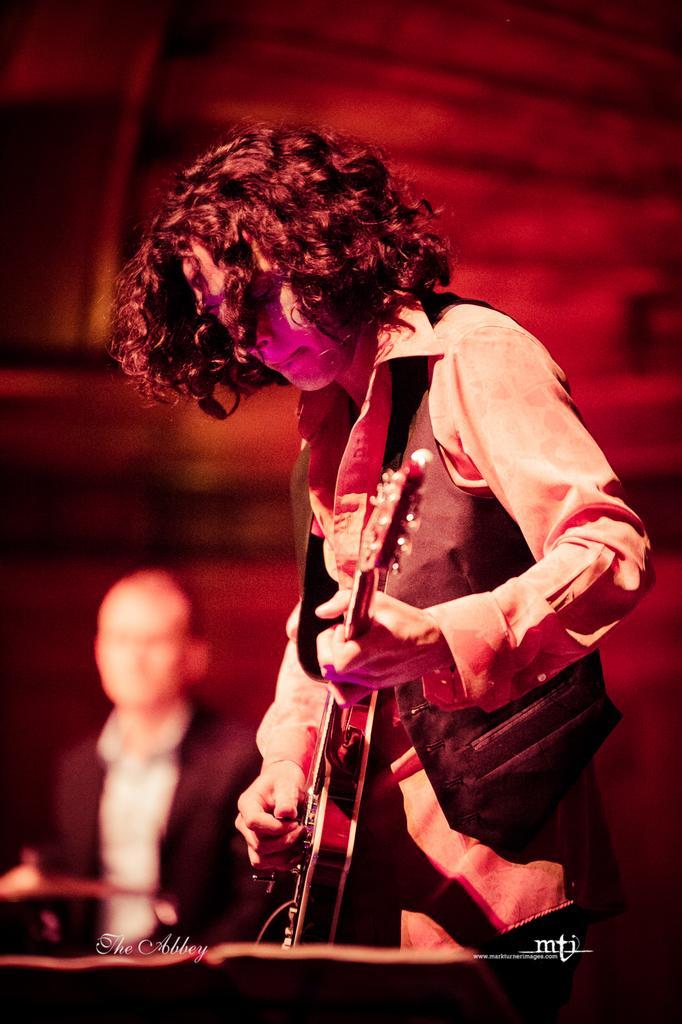Please provide a concise description of this image. In this picture a person is playing guitar, in the background we can see a person is seated. 